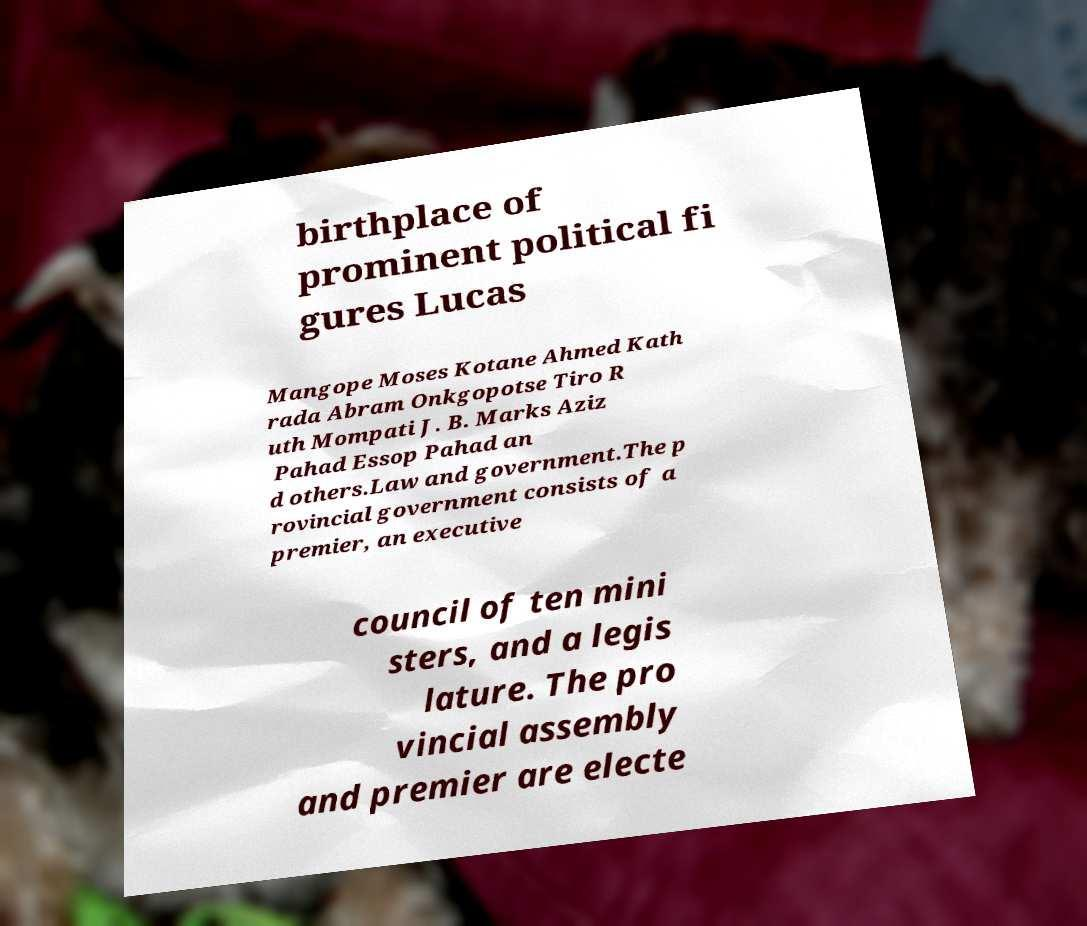There's text embedded in this image that I need extracted. Can you transcribe it verbatim? birthplace of prominent political fi gures Lucas Mangope Moses Kotane Ahmed Kath rada Abram Onkgopotse Tiro R uth Mompati J. B. Marks Aziz Pahad Essop Pahad an d others.Law and government.The p rovincial government consists of a premier, an executive council of ten mini sters, and a legis lature. The pro vincial assembly and premier are electe 